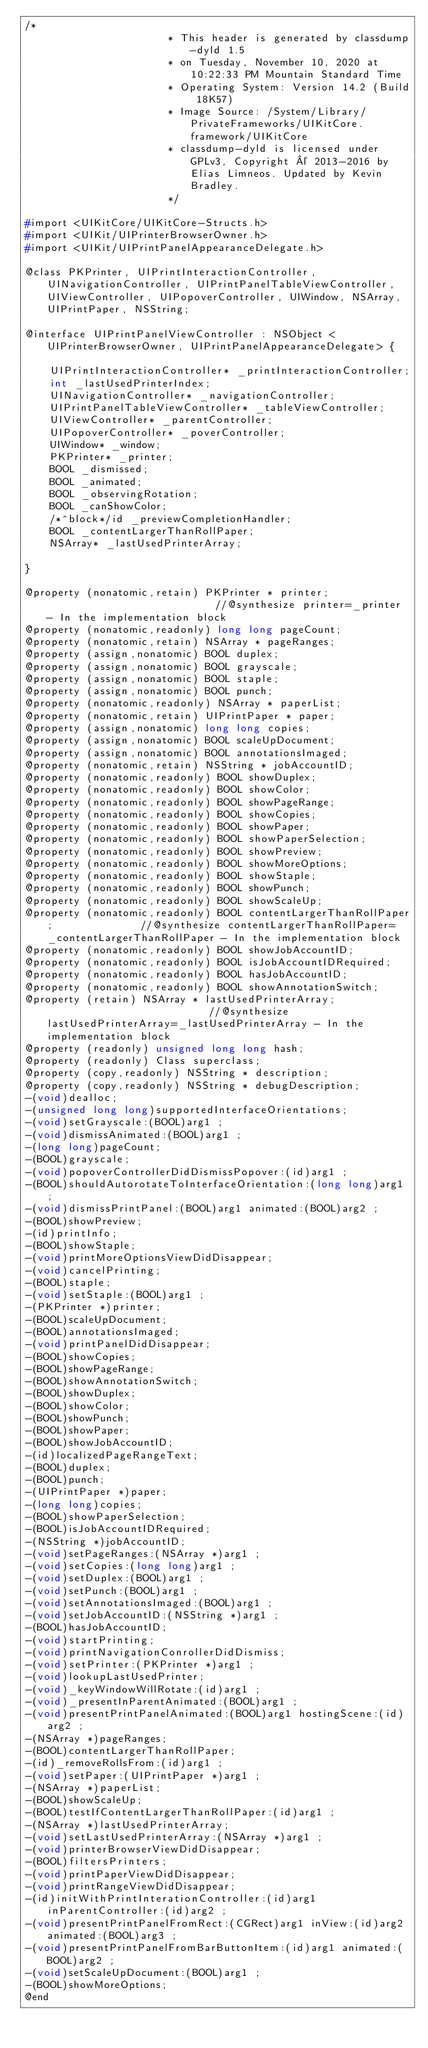Convert code to text. <code><loc_0><loc_0><loc_500><loc_500><_C_>/*
                       * This header is generated by classdump-dyld 1.5
                       * on Tuesday, November 10, 2020 at 10:22:33 PM Mountain Standard Time
                       * Operating System: Version 14.2 (Build 18K57)
                       * Image Source: /System/Library/PrivateFrameworks/UIKitCore.framework/UIKitCore
                       * classdump-dyld is licensed under GPLv3, Copyright © 2013-2016 by Elias Limneos. Updated by Kevin Bradley.
                       */

#import <UIKitCore/UIKitCore-Structs.h>
#import <UIKit/UIPrinterBrowserOwner.h>
#import <UIKit/UIPrintPanelAppearanceDelegate.h>

@class PKPrinter, UIPrintInteractionController, UINavigationController, UIPrintPanelTableViewController, UIViewController, UIPopoverController, UIWindow, NSArray, UIPrintPaper, NSString;

@interface UIPrintPanelViewController : NSObject <UIPrinterBrowserOwner, UIPrintPanelAppearanceDelegate> {

	UIPrintInteractionController* _printInteractionController;
	int _lastUsedPrinterIndex;
	UINavigationController* _navigationController;
	UIPrintPanelTableViewController* _tableViewController;
	UIViewController* _parentController;
	UIPopoverController* _poverController;
	UIWindow* _window;
	PKPrinter* _printer;
	BOOL _dismissed;
	BOOL _animated;
	BOOL _observingRotation;
	BOOL _canShowColor;
	/*^block*/id _previewCompletionHandler;
	BOOL _contentLargerThanRollPaper;
	NSArray* _lastUsedPrinterArray;

}

@property (nonatomic,retain) PKPrinter * printer;                            //@synthesize printer=_printer - In the implementation block
@property (nonatomic,readonly) long long pageCount; 
@property (nonatomic,retain) NSArray * pageRanges; 
@property (assign,nonatomic) BOOL duplex; 
@property (assign,nonatomic) BOOL grayscale; 
@property (assign,nonatomic) BOOL staple; 
@property (assign,nonatomic) BOOL punch; 
@property (nonatomic,readonly) NSArray * paperList; 
@property (nonatomic,retain) UIPrintPaper * paper; 
@property (assign,nonatomic) long long copies; 
@property (assign,nonatomic) BOOL scaleUpDocument; 
@property (assign,nonatomic) BOOL annotationsImaged; 
@property (nonatomic,retain) NSString * jobAccountID; 
@property (nonatomic,readonly) BOOL showDuplex; 
@property (nonatomic,readonly) BOOL showColor; 
@property (nonatomic,readonly) BOOL showPageRange; 
@property (nonatomic,readonly) BOOL showCopies; 
@property (nonatomic,readonly) BOOL showPaper; 
@property (nonatomic,readonly) BOOL showPaperSelection; 
@property (nonatomic,readonly) BOOL showPreview; 
@property (nonatomic,readonly) BOOL showMoreOptions; 
@property (nonatomic,readonly) BOOL showStaple; 
@property (nonatomic,readonly) BOOL showPunch; 
@property (nonatomic,readonly) BOOL showScaleUp; 
@property (nonatomic,readonly) BOOL contentLargerThanRollPaper;              //@synthesize contentLargerThanRollPaper=_contentLargerThanRollPaper - In the implementation block
@property (nonatomic,readonly) BOOL showJobAccountID; 
@property (nonatomic,readonly) BOOL isJobAccountIDRequired; 
@property (nonatomic,readonly) BOOL hasJobAccountID; 
@property (nonatomic,readonly) BOOL showAnnotationSwitch; 
@property (retain) NSArray * lastUsedPrinterArray;                           //@synthesize lastUsedPrinterArray=_lastUsedPrinterArray - In the implementation block
@property (readonly) unsigned long long hash; 
@property (readonly) Class superclass; 
@property (copy,readonly) NSString * description; 
@property (copy,readonly) NSString * debugDescription; 
-(void)dealloc;
-(unsigned long long)supportedInterfaceOrientations;
-(void)setGrayscale:(BOOL)arg1 ;
-(void)dismissAnimated:(BOOL)arg1 ;
-(long long)pageCount;
-(BOOL)grayscale;
-(void)popoverControllerDidDismissPopover:(id)arg1 ;
-(BOOL)shouldAutorotateToInterfaceOrientation:(long long)arg1 ;
-(void)dismissPrintPanel:(BOOL)arg1 animated:(BOOL)arg2 ;
-(BOOL)showPreview;
-(id)printInfo;
-(BOOL)showStaple;
-(void)printMoreOptionsViewDidDisappear;
-(void)cancelPrinting;
-(BOOL)staple;
-(void)setStaple:(BOOL)arg1 ;
-(PKPrinter *)printer;
-(BOOL)scaleUpDocument;
-(BOOL)annotationsImaged;
-(void)printPanelDidDisappear;
-(BOOL)showCopies;
-(BOOL)showPageRange;
-(BOOL)showAnnotationSwitch;
-(BOOL)showDuplex;
-(BOOL)showColor;
-(BOOL)showPunch;
-(BOOL)showPaper;
-(BOOL)showJobAccountID;
-(id)localizedPageRangeText;
-(BOOL)duplex;
-(BOOL)punch;
-(UIPrintPaper *)paper;
-(long long)copies;
-(BOOL)showPaperSelection;
-(BOOL)isJobAccountIDRequired;
-(NSString *)jobAccountID;
-(void)setPageRanges:(NSArray *)arg1 ;
-(void)setCopies:(long long)arg1 ;
-(void)setDuplex:(BOOL)arg1 ;
-(void)setPunch:(BOOL)arg1 ;
-(void)setAnnotationsImaged:(BOOL)arg1 ;
-(void)setJobAccountID:(NSString *)arg1 ;
-(BOOL)hasJobAccountID;
-(void)startPrinting;
-(void)printNavigationConrollerDidDismiss;
-(void)setPrinter:(PKPrinter *)arg1 ;
-(void)lookupLastUsedPrinter;
-(void)_keyWindowWillRotate:(id)arg1 ;
-(void)_presentInParentAnimated:(BOOL)arg1 ;
-(void)presentPrintPanelAnimated:(BOOL)arg1 hostingScene:(id)arg2 ;
-(NSArray *)pageRanges;
-(BOOL)contentLargerThanRollPaper;
-(id)_removeRollsFrom:(id)arg1 ;
-(void)setPaper:(UIPrintPaper *)arg1 ;
-(NSArray *)paperList;
-(BOOL)showScaleUp;
-(BOOL)testIfContentLargerThanRollPaper:(id)arg1 ;
-(NSArray *)lastUsedPrinterArray;
-(void)setLastUsedPrinterArray:(NSArray *)arg1 ;
-(void)printerBrowserViewDidDisappear;
-(BOOL)filtersPrinters;
-(void)printPaperViewDidDisappear;
-(void)printRangeViewDidDisappear;
-(id)initWithPrintInterationController:(id)arg1 inParentController:(id)arg2 ;
-(void)presentPrintPanelFromRect:(CGRect)arg1 inView:(id)arg2 animated:(BOOL)arg3 ;
-(void)presentPrintPanelFromBarButtonItem:(id)arg1 animated:(BOOL)arg2 ;
-(void)setScaleUpDocument:(BOOL)arg1 ;
-(BOOL)showMoreOptions;
@end

</code> 